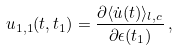Convert formula to latex. <formula><loc_0><loc_0><loc_500><loc_500>u _ { 1 , 1 } ( t , t _ { 1 } ) = \frac { \partial \langle \dot { u } ( t ) \rangle _ { l , c } } { \partial \epsilon ( t _ { 1 } ) } \, ,</formula> 